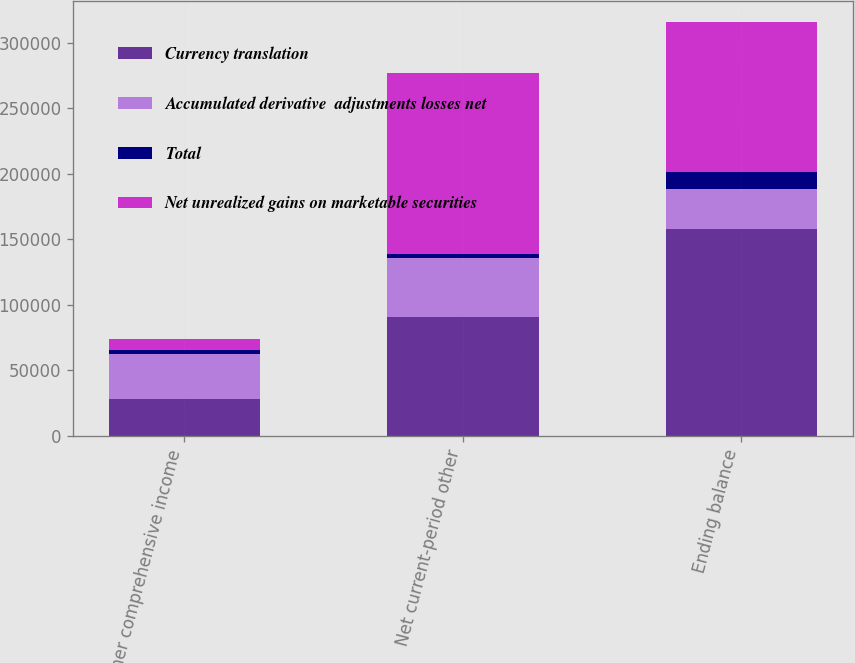Convert chart to OTSL. <chart><loc_0><loc_0><loc_500><loc_500><stacked_bar_chart><ecel><fcel>Other comprehensive income<fcel>Net current-period other<fcel>Ending balance<nl><fcel>Currency translation<fcel>28437<fcel>90421<fcel>157864<nl><fcel>Accumulated derivative  adjustments losses net<fcel>34400<fcel>45535<fcel>30374<nl><fcel>Total<fcel>2604<fcel>2604<fcel>13364<nl><fcel>Net unrealized gains on marketable securities<fcel>8567<fcel>138560<fcel>114126<nl></chart> 